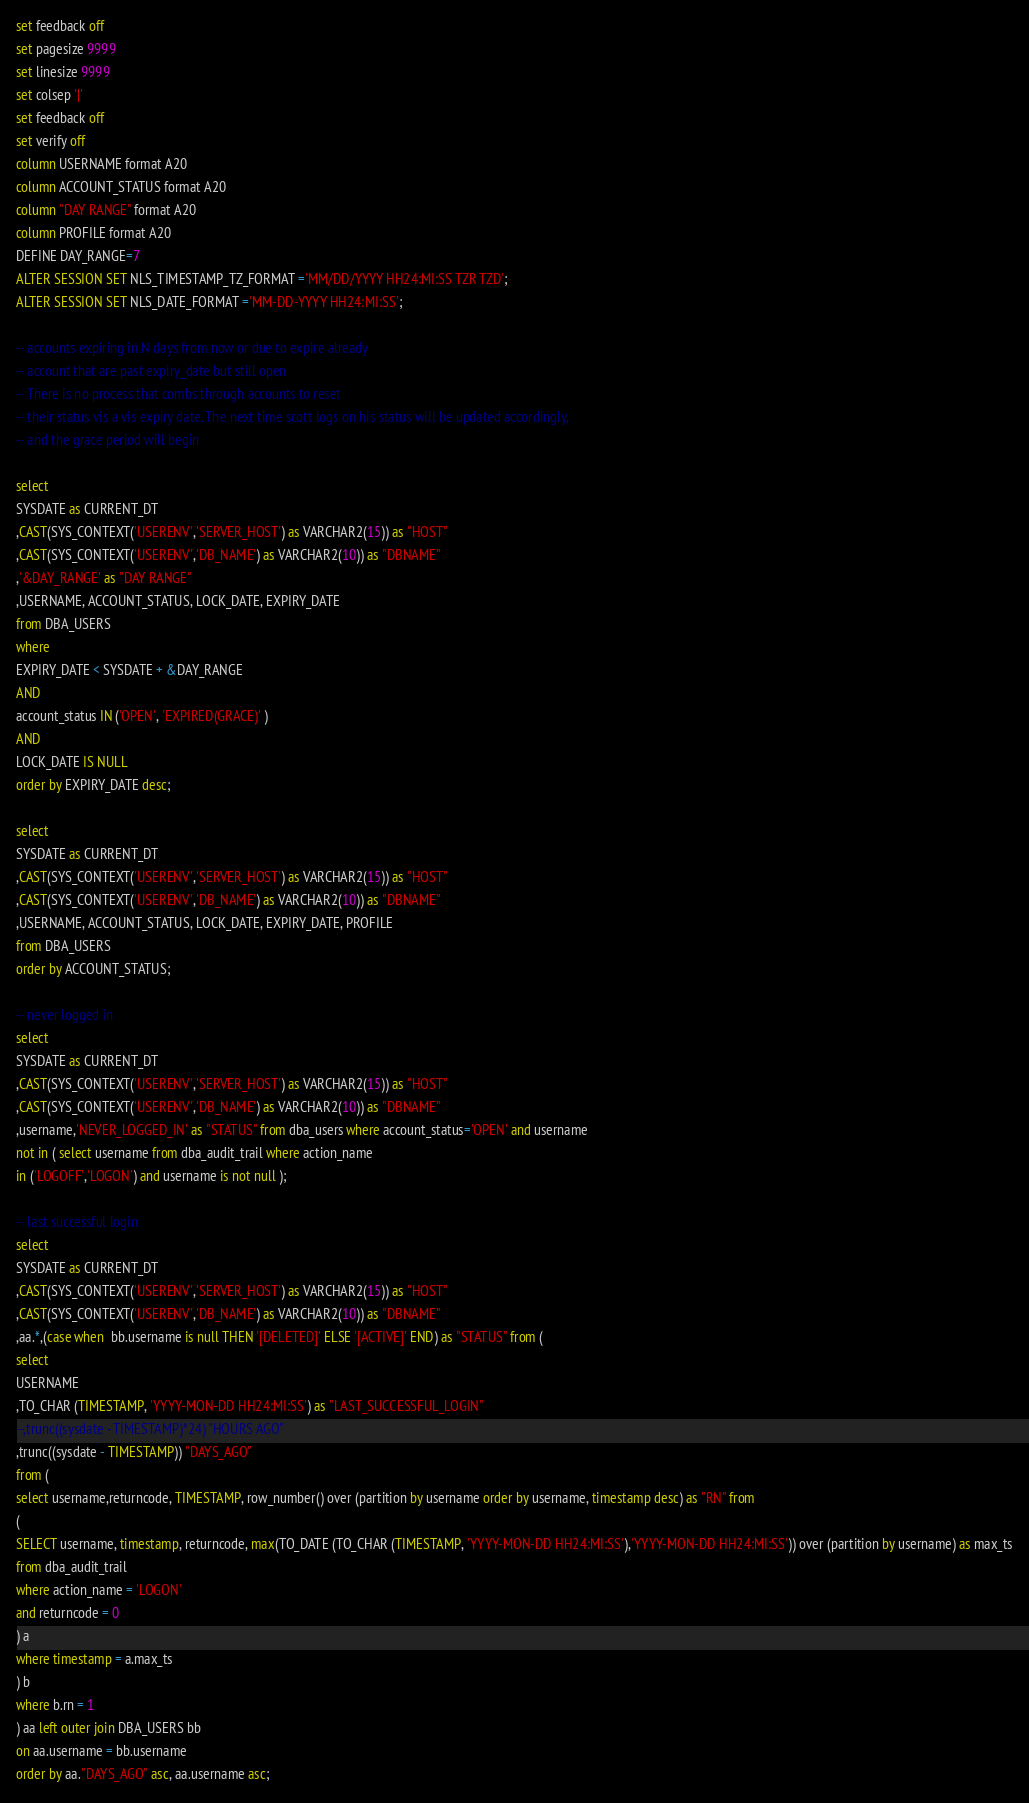<code> <loc_0><loc_0><loc_500><loc_500><_SQL_>set feedback off
set pagesize 9999
set linesize 9999
set colsep '|'
set feedback off
set verify off
column USERNAME format A20
column ACCOUNT_STATUS format A20
column "DAY RANGE" format A20
column PROFILE format A20
DEFINE DAY_RANGE=7
ALTER SESSION SET NLS_TIMESTAMP_TZ_FORMAT ='MM/DD/YYYY HH24:MI:SS TZR TZD';
ALTER SESSION SET NLS_DATE_FORMAT ='MM-DD-YYYY HH24:MI:SS';

-- accounts expiring in N days from now or due to expire already
-- account that are past expiry_date but still open
-- There is no process that combs through accounts to reset 
-- their status vis a vis expiry date. The next time scott logs on his status will be updated accordingly,
-- and the grace period will begin

select 
SYSDATE as CURRENT_DT
,CAST(SYS_CONTEXT('USERENV','SERVER_HOST') as VARCHAR2(15)) as "HOST"
,CAST(SYS_CONTEXT('USERENV','DB_NAME') as VARCHAR2(10)) as "DBNAME"
,'&DAY_RANGE' as "DAY RANGE"
,USERNAME, ACCOUNT_STATUS, LOCK_DATE, EXPIRY_DATE
from DBA_USERS
where 
EXPIRY_DATE < SYSDATE + &DAY_RANGE
AND
account_status IN ('OPEN', 'EXPIRED(GRACE)' )
AND
LOCK_DATE IS NULL
order by EXPIRY_DATE desc;

select 
SYSDATE as CURRENT_DT
,CAST(SYS_CONTEXT('USERENV','SERVER_HOST') as VARCHAR2(15)) as "HOST"
,CAST(SYS_CONTEXT('USERENV','DB_NAME') as VARCHAR2(10)) as "DBNAME"
,USERNAME, ACCOUNT_STATUS, LOCK_DATE, EXPIRY_DATE, PROFILE 
from DBA_USERS
order by ACCOUNT_STATUS;

-- never logged in
select 
SYSDATE as CURRENT_DT
,CAST(SYS_CONTEXT('USERENV','SERVER_HOST') as VARCHAR2(15)) as "HOST"
,CAST(SYS_CONTEXT('USERENV','DB_NAME') as VARCHAR2(10)) as "DBNAME"
,username,'NEVER_LOGGED_IN' as "STATUS" from dba_users where account_status='OPEN' and username 
not in ( select username from dba_audit_trail where action_name 
in ('LOGOFF','LOGON') and username is not null );

-- last successful login
select 
SYSDATE as CURRENT_DT
,CAST(SYS_CONTEXT('USERENV','SERVER_HOST') as VARCHAR2(15)) as "HOST"
,CAST(SYS_CONTEXT('USERENV','DB_NAME') as VARCHAR2(10)) as "DBNAME"
,aa.*,(case when  bb.username is null THEN '[DELETED]' ELSE '[ACTIVE]' END) as "STATUS" from (
select 
USERNAME
,TO_CHAR (TIMESTAMP, 'YYYY-MON-DD HH24:MI:SS') as "LAST_SUCCESSFUL_LOGIN" 
--,trunc((sysdate - TIMESTAMP)*24) "HOURS AGO"
,trunc((sysdate - TIMESTAMP)) "DAYS_AGO"
from (
select username,returncode, TIMESTAMP, row_number() over (partition by username order by username, timestamp desc) as "RN" from
(
SELECT username, timestamp, returncode, max(TO_DATE (TO_CHAR (TIMESTAMP, 'YYYY-MON-DD HH24:MI:SS'),'YYYY-MON-DD HH24:MI:SS')) over (partition by username) as max_ts
from dba_audit_trail
where action_name = 'LOGON'
and returncode = 0
) a
where timestamp = a.max_ts
) b
where b.rn = 1
) aa left outer join DBA_USERS bb
on aa.username = bb.username
order by aa."DAYS_AGO" asc, aa.username asc;

</code> 